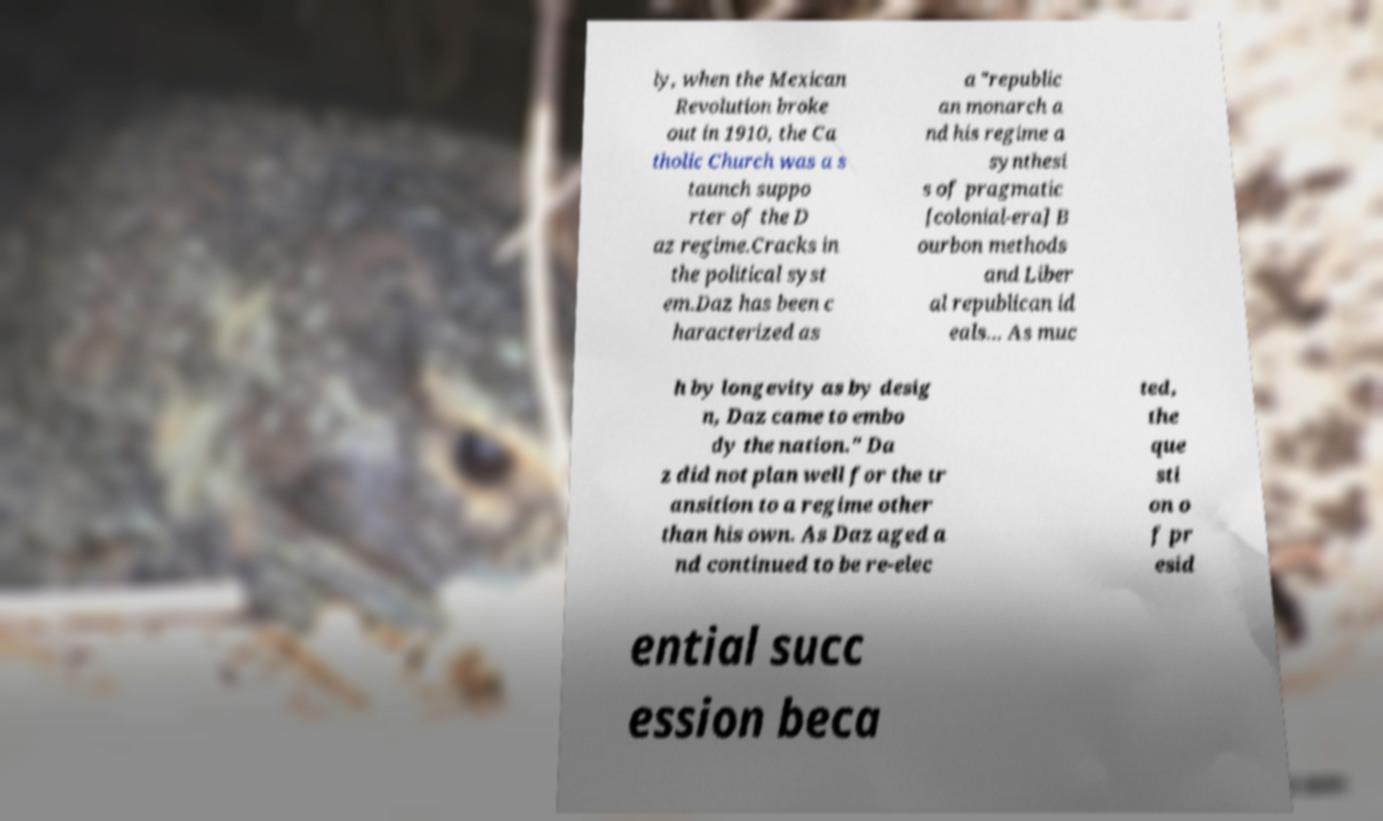Can you accurately transcribe the text from the provided image for me? ly, when the Mexican Revolution broke out in 1910, the Ca tholic Church was a s taunch suppo rter of the D az regime.Cracks in the political syst em.Daz has been c haracterized as a "republic an monarch a nd his regime a synthesi s of pragmatic [colonial-era] B ourbon methods and Liber al republican id eals... As muc h by longevity as by desig n, Daz came to embo dy the nation." Da z did not plan well for the tr ansition to a regime other than his own. As Daz aged a nd continued to be re-elec ted, the que sti on o f pr esid ential succ ession beca 